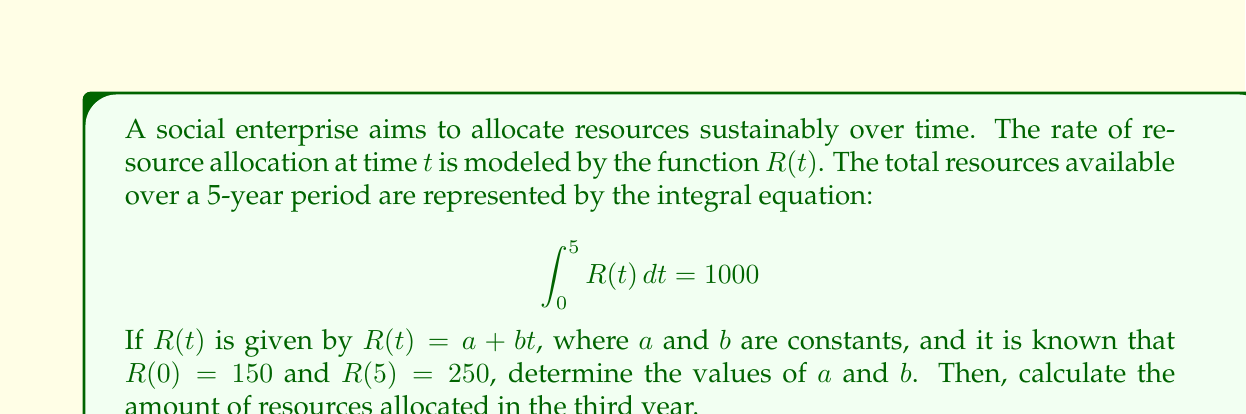Teach me how to tackle this problem. 1) Given $R(t) = a + bt$, we know that:
   $R(0) = a + b(0) = a = 150$
   $R(5) = a + b(5) = 250$

2) Substitute $a = 150$ into the equation for $R(5)$:
   $150 + 5b = 250$
   $5b = 100$
   $b = 20$

3) Now we have $R(t) = 150 + 20t$

4) To verify, let's solve the integral equation:
   $$\int_0^5 (150 + 20t) dt = 1000$$
   $$[150t + 10t^2]_0^5 = 1000$$
   $$(750 + 250) - (0 + 0) = 1000$$
   $$1000 = 1000$$ (verified)

5) To find resources allocated in the third year, we integrate from $t=2$ to $t=3$:
   $$\int_2^3 (150 + 20t) dt$$
   $$[150t + 10t^2]_2^3$$
   $$(450 + 90) - (300 + 40) = 200$$

Therefore, 200 units of resources are allocated in the third year.
Answer: $a = 150$, $b = 20$, 200 units in third year 